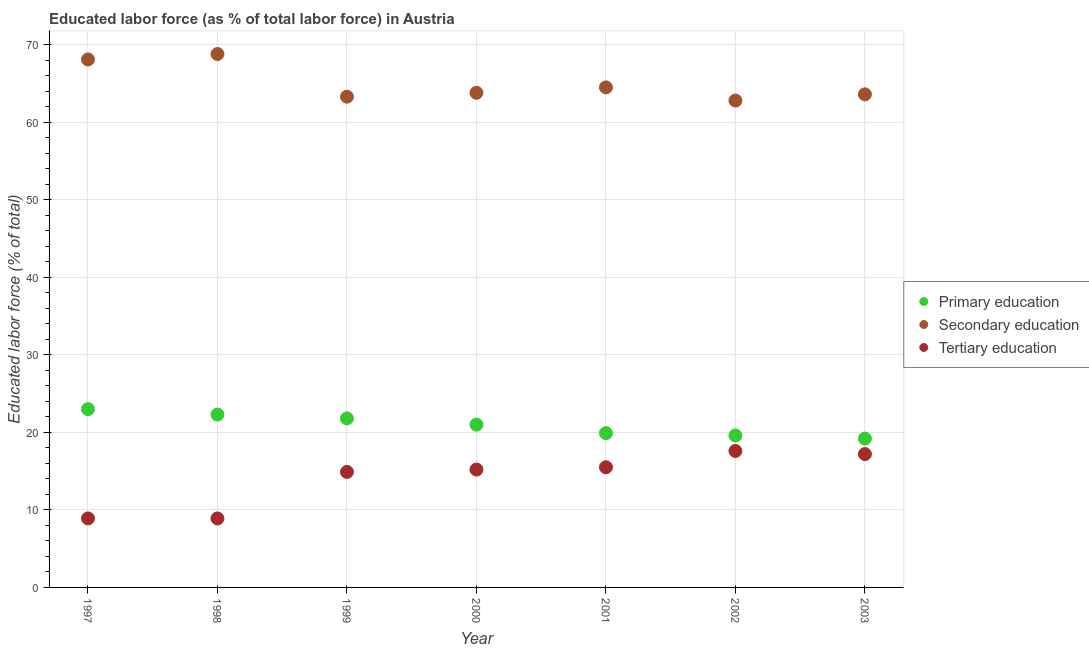What is the percentage of labor force who received primary education in 2003?
Your response must be concise. 19.2. Across all years, what is the maximum percentage of labor force who received tertiary education?
Offer a very short reply. 17.6. Across all years, what is the minimum percentage of labor force who received primary education?
Your response must be concise. 19.2. What is the total percentage of labor force who received secondary education in the graph?
Your response must be concise. 454.9. What is the difference between the percentage of labor force who received secondary education in 2000 and that in 2003?
Your answer should be compact. 0.2. What is the difference between the percentage of labor force who received secondary education in 1997 and the percentage of labor force who received tertiary education in 2003?
Offer a terse response. 50.9. What is the average percentage of labor force who received tertiary education per year?
Provide a succinct answer. 14.03. In the year 1999, what is the difference between the percentage of labor force who received tertiary education and percentage of labor force who received secondary education?
Your response must be concise. -48.4. What is the ratio of the percentage of labor force who received primary education in 1997 to that in 2001?
Offer a terse response. 1.16. What is the difference between the highest and the second highest percentage of labor force who received tertiary education?
Your answer should be compact. 0.4. What is the difference between the highest and the lowest percentage of labor force who received tertiary education?
Keep it short and to the point. 8.7. In how many years, is the percentage of labor force who received primary education greater than the average percentage of labor force who received primary education taken over all years?
Your answer should be compact. 4. Does the percentage of labor force who received secondary education monotonically increase over the years?
Offer a very short reply. No. Is the percentage of labor force who received secondary education strictly less than the percentage of labor force who received tertiary education over the years?
Provide a succinct answer. No. How many years are there in the graph?
Give a very brief answer. 7. Where does the legend appear in the graph?
Your answer should be compact. Center right. What is the title of the graph?
Make the answer very short. Educated labor force (as % of total labor force) in Austria. Does "Industry" appear as one of the legend labels in the graph?
Provide a succinct answer. No. What is the label or title of the Y-axis?
Provide a succinct answer. Educated labor force (% of total). What is the Educated labor force (% of total) of Primary education in 1997?
Provide a succinct answer. 23. What is the Educated labor force (% of total) of Secondary education in 1997?
Keep it short and to the point. 68.1. What is the Educated labor force (% of total) in Tertiary education in 1997?
Keep it short and to the point. 8.9. What is the Educated labor force (% of total) in Primary education in 1998?
Offer a terse response. 22.3. What is the Educated labor force (% of total) of Secondary education in 1998?
Offer a very short reply. 68.8. What is the Educated labor force (% of total) in Tertiary education in 1998?
Give a very brief answer. 8.9. What is the Educated labor force (% of total) of Primary education in 1999?
Ensure brevity in your answer.  21.8. What is the Educated labor force (% of total) of Secondary education in 1999?
Your answer should be compact. 63.3. What is the Educated labor force (% of total) in Tertiary education in 1999?
Offer a terse response. 14.9. What is the Educated labor force (% of total) of Secondary education in 2000?
Provide a succinct answer. 63.8. What is the Educated labor force (% of total) of Tertiary education in 2000?
Provide a short and direct response. 15.2. What is the Educated labor force (% of total) of Primary education in 2001?
Your answer should be compact. 19.9. What is the Educated labor force (% of total) in Secondary education in 2001?
Ensure brevity in your answer.  64.5. What is the Educated labor force (% of total) of Tertiary education in 2001?
Offer a very short reply. 15.5. What is the Educated labor force (% of total) of Primary education in 2002?
Offer a terse response. 19.6. What is the Educated labor force (% of total) of Secondary education in 2002?
Keep it short and to the point. 62.8. What is the Educated labor force (% of total) in Tertiary education in 2002?
Offer a very short reply. 17.6. What is the Educated labor force (% of total) in Primary education in 2003?
Your answer should be compact. 19.2. What is the Educated labor force (% of total) in Secondary education in 2003?
Your answer should be very brief. 63.6. What is the Educated labor force (% of total) in Tertiary education in 2003?
Make the answer very short. 17.2. Across all years, what is the maximum Educated labor force (% of total) in Primary education?
Offer a very short reply. 23. Across all years, what is the maximum Educated labor force (% of total) of Secondary education?
Provide a short and direct response. 68.8. Across all years, what is the maximum Educated labor force (% of total) in Tertiary education?
Give a very brief answer. 17.6. Across all years, what is the minimum Educated labor force (% of total) of Primary education?
Offer a very short reply. 19.2. Across all years, what is the minimum Educated labor force (% of total) of Secondary education?
Your answer should be compact. 62.8. Across all years, what is the minimum Educated labor force (% of total) in Tertiary education?
Your answer should be very brief. 8.9. What is the total Educated labor force (% of total) in Primary education in the graph?
Your answer should be compact. 146.8. What is the total Educated labor force (% of total) of Secondary education in the graph?
Your answer should be very brief. 454.9. What is the total Educated labor force (% of total) of Tertiary education in the graph?
Provide a succinct answer. 98.2. What is the difference between the Educated labor force (% of total) of Primary education in 1997 and that in 1998?
Provide a short and direct response. 0.7. What is the difference between the Educated labor force (% of total) of Tertiary education in 1997 and that in 1998?
Ensure brevity in your answer.  0. What is the difference between the Educated labor force (% of total) in Tertiary education in 1997 and that in 1999?
Give a very brief answer. -6. What is the difference between the Educated labor force (% of total) of Secondary education in 1997 and that in 2000?
Your answer should be very brief. 4.3. What is the difference between the Educated labor force (% of total) of Tertiary education in 1997 and that in 2000?
Keep it short and to the point. -6.3. What is the difference between the Educated labor force (% of total) of Primary education in 1997 and that in 2001?
Offer a terse response. 3.1. What is the difference between the Educated labor force (% of total) in Tertiary education in 1997 and that in 2001?
Your answer should be compact. -6.6. What is the difference between the Educated labor force (% of total) of Primary education in 1997 and that in 2002?
Give a very brief answer. 3.4. What is the difference between the Educated labor force (% of total) of Secondary education in 1997 and that in 2003?
Provide a short and direct response. 4.5. What is the difference between the Educated labor force (% of total) in Tertiary education in 1997 and that in 2003?
Ensure brevity in your answer.  -8.3. What is the difference between the Educated labor force (% of total) in Tertiary education in 1998 and that in 1999?
Your response must be concise. -6. What is the difference between the Educated labor force (% of total) of Primary education in 1998 and that in 2000?
Your response must be concise. 1.3. What is the difference between the Educated labor force (% of total) of Secondary education in 1998 and that in 2000?
Your response must be concise. 5. What is the difference between the Educated labor force (% of total) of Tertiary education in 1998 and that in 2000?
Keep it short and to the point. -6.3. What is the difference between the Educated labor force (% of total) in Primary education in 1998 and that in 2001?
Give a very brief answer. 2.4. What is the difference between the Educated labor force (% of total) of Primary education in 1998 and that in 2002?
Your response must be concise. 2.7. What is the difference between the Educated labor force (% of total) in Secondary education in 1998 and that in 2002?
Your answer should be compact. 6. What is the difference between the Educated labor force (% of total) in Tertiary education in 1998 and that in 2002?
Keep it short and to the point. -8.7. What is the difference between the Educated labor force (% of total) of Secondary education in 1998 and that in 2003?
Your answer should be compact. 5.2. What is the difference between the Educated labor force (% of total) in Tertiary education in 1998 and that in 2003?
Keep it short and to the point. -8.3. What is the difference between the Educated labor force (% of total) in Primary education in 1999 and that in 2000?
Make the answer very short. 0.8. What is the difference between the Educated labor force (% of total) of Secondary education in 1999 and that in 2000?
Keep it short and to the point. -0.5. What is the difference between the Educated labor force (% of total) of Tertiary education in 1999 and that in 2000?
Make the answer very short. -0.3. What is the difference between the Educated labor force (% of total) in Secondary education in 1999 and that in 2001?
Give a very brief answer. -1.2. What is the difference between the Educated labor force (% of total) in Tertiary education in 1999 and that in 2001?
Offer a very short reply. -0.6. What is the difference between the Educated labor force (% of total) of Primary education in 1999 and that in 2002?
Ensure brevity in your answer.  2.2. What is the difference between the Educated labor force (% of total) in Secondary education in 1999 and that in 2002?
Your response must be concise. 0.5. What is the difference between the Educated labor force (% of total) in Primary education in 1999 and that in 2003?
Make the answer very short. 2.6. What is the difference between the Educated labor force (% of total) of Secondary education in 2000 and that in 2001?
Give a very brief answer. -0.7. What is the difference between the Educated labor force (% of total) in Primary education in 2000 and that in 2002?
Your response must be concise. 1.4. What is the difference between the Educated labor force (% of total) in Primary education in 2000 and that in 2003?
Give a very brief answer. 1.8. What is the difference between the Educated labor force (% of total) in Primary education in 2001 and that in 2003?
Give a very brief answer. 0.7. What is the difference between the Educated labor force (% of total) of Tertiary education in 2001 and that in 2003?
Keep it short and to the point. -1.7. What is the difference between the Educated labor force (% of total) of Tertiary education in 2002 and that in 2003?
Your answer should be compact. 0.4. What is the difference between the Educated labor force (% of total) of Primary education in 1997 and the Educated labor force (% of total) of Secondary education in 1998?
Offer a terse response. -45.8. What is the difference between the Educated labor force (% of total) of Primary education in 1997 and the Educated labor force (% of total) of Tertiary education in 1998?
Provide a short and direct response. 14.1. What is the difference between the Educated labor force (% of total) of Secondary education in 1997 and the Educated labor force (% of total) of Tertiary education in 1998?
Your answer should be compact. 59.2. What is the difference between the Educated labor force (% of total) of Primary education in 1997 and the Educated labor force (% of total) of Secondary education in 1999?
Your answer should be compact. -40.3. What is the difference between the Educated labor force (% of total) of Primary education in 1997 and the Educated labor force (% of total) of Tertiary education in 1999?
Give a very brief answer. 8.1. What is the difference between the Educated labor force (% of total) of Secondary education in 1997 and the Educated labor force (% of total) of Tertiary education in 1999?
Provide a short and direct response. 53.2. What is the difference between the Educated labor force (% of total) in Primary education in 1997 and the Educated labor force (% of total) in Secondary education in 2000?
Your response must be concise. -40.8. What is the difference between the Educated labor force (% of total) of Secondary education in 1997 and the Educated labor force (% of total) of Tertiary education in 2000?
Make the answer very short. 52.9. What is the difference between the Educated labor force (% of total) in Primary education in 1997 and the Educated labor force (% of total) in Secondary education in 2001?
Provide a short and direct response. -41.5. What is the difference between the Educated labor force (% of total) of Secondary education in 1997 and the Educated labor force (% of total) of Tertiary education in 2001?
Keep it short and to the point. 52.6. What is the difference between the Educated labor force (% of total) in Primary education in 1997 and the Educated labor force (% of total) in Secondary education in 2002?
Your answer should be compact. -39.8. What is the difference between the Educated labor force (% of total) of Secondary education in 1997 and the Educated labor force (% of total) of Tertiary education in 2002?
Your answer should be compact. 50.5. What is the difference between the Educated labor force (% of total) of Primary education in 1997 and the Educated labor force (% of total) of Secondary education in 2003?
Provide a short and direct response. -40.6. What is the difference between the Educated labor force (% of total) of Primary education in 1997 and the Educated labor force (% of total) of Tertiary education in 2003?
Make the answer very short. 5.8. What is the difference between the Educated labor force (% of total) of Secondary education in 1997 and the Educated labor force (% of total) of Tertiary education in 2003?
Make the answer very short. 50.9. What is the difference between the Educated labor force (% of total) in Primary education in 1998 and the Educated labor force (% of total) in Secondary education in 1999?
Ensure brevity in your answer.  -41. What is the difference between the Educated labor force (% of total) of Primary education in 1998 and the Educated labor force (% of total) of Tertiary education in 1999?
Offer a very short reply. 7.4. What is the difference between the Educated labor force (% of total) in Secondary education in 1998 and the Educated labor force (% of total) in Tertiary education in 1999?
Your answer should be very brief. 53.9. What is the difference between the Educated labor force (% of total) of Primary education in 1998 and the Educated labor force (% of total) of Secondary education in 2000?
Provide a short and direct response. -41.5. What is the difference between the Educated labor force (% of total) in Secondary education in 1998 and the Educated labor force (% of total) in Tertiary education in 2000?
Give a very brief answer. 53.6. What is the difference between the Educated labor force (% of total) of Primary education in 1998 and the Educated labor force (% of total) of Secondary education in 2001?
Your response must be concise. -42.2. What is the difference between the Educated labor force (% of total) in Secondary education in 1998 and the Educated labor force (% of total) in Tertiary education in 2001?
Ensure brevity in your answer.  53.3. What is the difference between the Educated labor force (% of total) of Primary education in 1998 and the Educated labor force (% of total) of Secondary education in 2002?
Your answer should be compact. -40.5. What is the difference between the Educated labor force (% of total) of Primary education in 1998 and the Educated labor force (% of total) of Tertiary education in 2002?
Make the answer very short. 4.7. What is the difference between the Educated labor force (% of total) of Secondary education in 1998 and the Educated labor force (% of total) of Tertiary education in 2002?
Make the answer very short. 51.2. What is the difference between the Educated labor force (% of total) in Primary education in 1998 and the Educated labor force (% of total) in Secondary education in 2003?
Give a very brief answer. -41.3. What is the difference between the Educated labor force (% of total) of Primary education in 1998 and the Educated labor force (% of total) of Tertiary education in 2003?
Your answer should be compact. 5.1. What is the difference between the Educated labor force (% of total) in Secondary education in 1998 and the Educated labor force (% of total) in Tertiary education in 2003?
Make the answer very short. 51.6. What is the difference between the Educated labor force (% of total) in Primary education in 1999 and the Educated labor force (% of total) in Secondary education in 2000?
Keep it short and to the point. -42. What is the difference between the Educated labor force (% of total) in Primary education in 1999 and the Educated labor force (% of total) in Tertiary education in 2000?
Keep it short and to the point. 6.6. What is the difference between the Educated labor force (% of total) in Secondary education in 1999 and the Educated labor force (% of total) in Tertiary education in 2000?
Your answer should be compact. 48.1. What is the difference between the Educated labor force (% of total) in Primary education in 1999 and the Educated labor force (% of total) in Secondary education in 2001?
Make the answer very short. -42.7. What is the difference between the Educated labor force (% of total) in Secondary education in 1999 and the Educated labor force (% of total) in Tertiary education in 2001?
Offer a very short reply. 47.8. What is the difference between the Educated labor force (% of total) of Primary education in 1999 and the Educated labor force (% of total) of Secondary education in 2002?
Your response must be concise. -41. What is the difference between the Educated labor force (% of total) of Secondary education in 1999 and the Educated labor force (% of total) of Tertiary education in 2002?
Make the answer very short. 45.7. What is the difference between the Educated labor force (% of total) in Primary education in 1999 and the Educated labor force (% of total) in Secondary education in 2003?
Provide a succinct answer. -41.8. What is the difference between the Educated labor force (% of total) in Secondary education in 1999 and the Educated labor force (% of total) in Tertiary education in 2003?
Offer a terse response. 46.1. What is the difference between the Educated labor force (% of total) in Primary education in 2000 and the Educated labor force (% of total) in Secondary education in 2001?
Keep it short and to the point. -43.5. What is the difference between the Educated labor force (% of total) in Secondary education in 2000 and the Educated labor force (% of total) in Tertiary education in 2001?
Your answer should be compact. 48.3. What is the difference between the Educated labor force (% of total) of Primary education in 2000 and the Educated labor force (% of total) of Secondary education in 2002?
Your answer should be very brief. -41.8. What is the difference between the Educated labor force (% of total) in Primary education in 2000 and the Educated labor force (% of total) in Tertiary education in 2002?
Keep it short and to the point. 3.4. What is the difference between the Educated labor force (% of total) of Secondary education in 2000 and the Educated labor force (% of total) of Tertiary education in 2002?
Ensure brevity in your answer.  46.2. What is the difference between the Educated labor force (% of total) in Primary education in 2000 and the Educated labor force (% of total) in Secondary education in 2003?
Provide a succinct answer. -42.6. What is the difference between the Educated labor force (% of total) of Secondary education in 2000 and the Educated labor force (% of total) of Tertiary education in 2003?
Your answer should be very brief. 46.6. What is the difference between the Educated labor force (% of total) of Primary education in 2001 and the Educated labor force (% of total) of Secondary education in 2002?
Your answer should be compact. -42.9. What is the difference between the Educated labor force (% of total) of Secondary education in 2001 and the Educated labor force (% of total) of Tertiary education in 2002?
Provide a short and direct response. 46.9. What is the difference between the Educated labor force (% of total) in Primary education in 2001 and the Educated labor force (% of total) in Secondary education in 2003?
Ensure brevity in your answer.  -43.7. What is the difference between the Educated labor force (% of total) of Primary education in 2001 and the Educated labor force (% of total) of Tertiary education in 2003?
Give a very brief answer. 2.7. What is the difference between the Educated labor force (% of total) in Secondary education in 2001 and the Educated labor force (% of total) in Tertiary education in 2003?
Your response must be concise. 47.3. What is the difference between the Educated labor force (% of total) of Primary education in 2002 and the Educated labor force (% of total) of Secondary education in 2003?
Your answer should be compact. -44. What is the difference between the Educated labor force (% of total) in Primary education in 2002 and the Educated labor force (% of total) in Tertiary education in 2003?
Provide a succinct answer. 2.4. What is the difference between the Educated labor force (% of total) of Secondary education in 2002 and the Educated labor force (% of total) of Tertiary education in 2003?
Provide a succinct answer. 45.6. What is the average Educated labor force (% of total) in Primary education per year?
Your answer should be compact. 20.97. What is the average Educated labor force (% of total) of Secondary education per year?
Your answer should be very brief. 64.99. What is the average Educated labor force (% of total) of Tertiary education per year?
Offer a very short reply. 14.03. In the year 1997, what is the difference between the Educated labor force (% of total) in Primary education and Educated labor force (% of total) in Secondary education?
Offer a very short reply. -45.1. In the year 1997, what is the difference between the Educated labor force (% of total) of Secondary education and Educated labor force (% of total) of Tertiary education?
Keep it short and to the point. 59.2. In the year 1998, what is the difference between the Educated labor force (% of total) of Primary education and Educated labor force (% of total) of Secondary education?
Your answer should be very brief. -46.5. In the year 1998, what is the difference between the Educated labor force (% of total) of Primary education and Educated labor force (% of total) of Tertiary education?
Make the answer very short. 13.4. In the year 1998, what is the difference between the Educated labor force (% of total) in Secondary education and Educated labor force (% of total) in Tertiary education?
Offer a terse response. 59.9. In the year 1999, what is the difference between the Educated labor force (% of total) in Primary education and Educated labor force (% of total) in Secondary education?
Offer a terse response. -41.5. In the year 1999, what is the difference between the Educated labor force (% of total) in Primary education and Educated labor force (% of total) in Tertiary education?
Provide a short and direct response. 6.9. In the year 1999, what is the difference between the Educated labor force (% of total) in Secondary education and Educated labor force (% of total) in Tertiary education?
Offer a terse response. 48.4. In the year 2000, what is the difference between the Educated labor force (% of total) in Primary education and Educated labor force (% of total) in Secondary education?
Your response must be concise. -42.8. In the year 2000, what is the difference between the Educated labor force (% of total) of Secondary education and Educated labor force (% of total) of Tertiary education?
Provide a short and direct response. 48.6. In the year 2001, what is the difference between the Educated labor force (% of total) in Primary education and Educated labor force (% of total) in Secondary education?
Keep it short and to the point. -44.6. In the year 2002, what is the difference between the Educated labor force (% of total) in Primary education and Educated labor force (% of total) in Secondary education?
Provide a succinct answer. -43.2. In the year 2002, what is the difference between the Educated labor force (% of total) of Secondary education and Educated labor force (% of total) of Tertiary education?
Keep it short and to the point. 45.2. In the year 2003, what is the difference between the Educated labor force (% of total) of Primary education and Educated labor force (% of total) of Secondary education?
Your answer should be very brief. -44.4. In the year 2003, what is the difference between the Educated labor force (% of total) of Primary education and Educated labor force (% of total) of Tertiary education?
Offer a terse response. 2. In the year 2003, what is the difference between the Educated labor force (% of total) in Secondary education and Educated labor force (% of total) in Tertiary education?
Make the answer very short. 46.4. What is the ratio of the Educated labor force (% of total) in Primary education in 1997 to that in 1998?
Keep it short and to the point. 1.03. What is the ratio of the Educated labor force (% of total) in Tertiary education in 1997 to that in 1998?
Offer a terse response. 1. What is the ratio of the Educated labor force (% of total) in Primary education in 1997 to that in 1999?
Make the answer very short. 1.05. What is the ratio of the Educated labor force (% of total) in Secondary education in 1997 to that in 1999?
Ensure brevity in your answer.  1.08. What is the ratio of the Educated labor force (% of total) in Tertiary education in 1997 to that in 1999?
Make the answer very short. 0.6. What is the ratio of the Educated labor force (% of total) in Primary education in 1997 to that in 2000?
Keep it short and to the point. 1.1. What is the ratio of the Educated labor force (% of total) of Secondary education in 1997 to that in 2000?
Give a very brief answer. 1.07. What is the ratio of the Educated labor force (% of total) of Tertiary education in 1997 to that in 2000?
Your response must be concise. 0.59. What is the ratio of the Educated labor force (% of total) in Primary education in 1997 to that in 2001?
Your answer should be very brief. 1.16. What is the ratio of the Educated labor force (% of total) of Secondary education in 1997 to that in 2001?
Provide a short and direct response. 1.06. What is the ratio of the Educated labor force (% of total) in Tertiary education in 1997 to that in 2001?
Offer a terse response. 0.57. What is the ratio of the Educated labor force (% of total) in Primary education in 1997 to that in 2002?
Your response must be concise. 1.17. What is the ratio of the Educated labor force (% of total) of Secondary education in 1997 to that in 2002?
Offer a very short reply. 1.08. What is the ratio of the Educated labor force (% of total) of Tertiary education in 1997 to that in 2002?
Ensure brevity in your answer.  0.51. What is the ratio of the Educated labor force (% of total) in Primary education in 1997 to that in 2003?
Your answer should be compact. 1.2. What is the ratio of the Educated labor force (% of total) in Secondary education in 1997 to that in 2003?
Provide a short and direct response. 1.07. What is the ratio of the Educated labor force (% of total) of Tertiary education in 1997 to that in 2003?
Provide a short and direct response. 0.52. What is the ratio of the Educated labor force (% of total) in Primary education in 1998 to that in 1999?
Provide a short and direct response. 1.02. What is the ratio of the Educated labor force (% of total) of Secondary education in 1998 to that in 1999?
Ensure brevity in your answer.  1.09. What is the ratio of the Educated labor force (% of total) in Tertiary education in 1998 to that in 1999?
Your answer should be very brief. 0.6. What is the ratio of the Educated labor force (% of total) in Primary education in 1998 to that in 2000?
Keep it short and to the point. 1.06. What is the ratio of the Educated labor force (% of total) of Secondary education in 1998 to that in 2000?
Offer a terse response. 1.08. What is the ratio of the Educated labor force (% of total) of Tertiary education in 1998 to that in 2000?
Provide a succinct answer. 0.59. What is the ratio of the Educated labor force (% of total) in Primary education in 1998 to that in 2001?
Your response must be concise. 1.12. What is the ratio of the Educated labor force (% of total) of Secondary education in 1998 to that in 2001?
Your response must be concise. 1.07. What is the ratio of the Educated labor force (% of total) in Tertiary education in 1998 to that in 2001?
Your answer should be very brief. 0.57. What is the ratio of the Educated labor force (% of total) of Primary education in 1998 to that in 2002?
Give a very brief answer. 1.14. What is the ratio of the Educated labor force (% of total) in Secondary education in 1998 to that in 2002?
Your answer should be compact. 1.1. What is the ratio of the Educated labor force (% of total) of Tertiary education in 1998 to that in 2002?
Offer a very short reply. 0.51. What is the ratio of the Educated labor force (% of total) in Primary education in 1998 to that in 2003?
Provide a short and direct response. 1.16. What is the ratio of the Educated labor force (% of total) of Secondary education in 1998 to that in 2003?
Your response must be concise. 1.08. What is the ratio of the Educated labor force (% of total) in Tertiary education in 1998 to that in 2003?
Your answer should be very brief. 0.52. What is the ratio of the Educated labor force (% of total) of Primary education in 1999 to that in 2000?
Ensure brevity in your answer.  1.04. What is the ratio of the Educated labor force (% of total) in Tertiary education in 1999 to that in 2000?
Provide a succinct answer. 0.98. What is the ratio of the Educated labor force (% of total) of Primary education in 1999 to that in 2001?
Give a very brief answer. 1.1. What is the ratio of the Educated labor force (% of total) of Secondary education in 1999 to that in 2001?
Your answer should be compact. 0.98. What is the ratio of the Educated labor force (% of total) of Tertiary education in 1999 to that in 2001?
Give a very brief answer. 0.96. What is the ratio of the Educated labor force (% of total) in Primary education in 1999 to that in 2002?
Provide a succinct answer. 1.11. What is the ratio of the Educated labor force (% of total) in Secondary education in 1999 to that in 2002?
Your answer should be very brief. 1.01. What is the ratio of the Educated labor force (% of total) in Tertiary education in 1999 to that in 2002?
Ensure brevity in your answer.  0.85. What is the ratio of the Educated labor force (% of total) in Primary education in 1999 to that in 2003?
Give a very brief answer. 1.14. What is the ratio of the Educated labor force (% of total) of Tertiary education in 1999 to that in 2003?
Give a very brief answer. 0.87. What is the ratio of the Educated labor force (% of total) of Primary education in 2000 to that in 2001?
Offer a very short reply. 1.06. What is the ratio of the Educated labor force (% of total) of Tertiary education in 2000 to that in 2001?
Offer a very short reply. 0.98. What is the ratio of the Educated labor force (% of total) in Primary education in 2000 to that in 2002?
Provide a succinct answer. 1.07. What is the ratio of the Educated labor force (% of total) in Secondary education in 2000 to that in 2002?
Your answer should be very brief. 1.02. What is the ratio of the Educated labor force (% of total) of Tertiary education in 2000 to that in 2002?
Offer a very short reply. 0.86. What is the ratio of the Educated labor force (% of total) in Primary education in 2000 to that in 2003?
Your response must be concise. 1.09. What is the ratio of the Educated labor force (% of total) in Secondary education in 2000 to that in 2003?
Your answer should be compact. 1. What is the ratio of the Educated labor force (% of total) in Tertiary education in 2000 to that in 2003?
Your response must be concise. 0.88. What is the ratio of the Educated labor force (% of total) in Primary education in 2001 to that in 2002?
Provide a short and direct response. 1.02. What is the ratio of the Educated labor force (% of total) of Secondary education in 2001 to that in 2002?
Your response must be concise. 1.03. What is the ratio of the Educated labor force (% of total) of Tertiary education in 2001 to that in 2002?
Offer a terse response. 0.88. What is the ratio of the Educated labor force (% of total) in Primary education in 2001 to that in 2003?
Your answer should be very brief. 1.04. What is the ratio of the Educated labor force (% of total) of Secondary education in 2001 to that in 2003?
Ensure brevity in your answer.  1.01. What is the ratio of the Educated labor force (% of total) of Tertiary education in 2001 to that in 2003?
Keep it short and to the point. 0.9. What is the ratio of the Educated labor force (% of total) of Primary education in 2002 to that in 2003?
Provide a short and direct response. 1.02. What is the ratio of the Educated labor force (% of total) in Secondary education in 2002 to that in 2003?
Your answer should be compact. 0.99. What is the ratio of the Educated labor force (% of total) in Tertiary education in 2002 to that in 2003?
Offer a terse response. 1.02. What is the difference between the highest and the lowest Educated labor force (% of total) of Primary education?
Offer a very short reply. 3.8. What is the difference between the highest and the lowest Educated labor force (% of total) of Secondary education?
Your answer should be very brief. 6. What is the difference between the highest and the lowest Educated labor force (% of total) of Tertiary education?
Offer a very short reply. 8.7. 